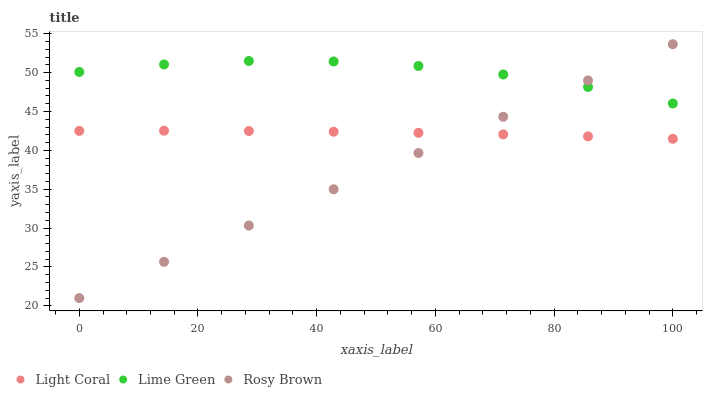Does Rosy Brown have the minimum area under the curve?
Answer yes or no. Yes. Does Lime Green have the maximum area under the curve?
Answer yes or no. Yes. Does Lime Green have the minimum area under the curve?
Answer yes or no. No. Does Rosy Brown have the maximum area under the curve?
Answer yes or no. No. Is Rosy Brown the smoothest?
Answer yes or no. Yes. Is Lime Green the roughest?
Answer yes or no. Yes. Is Lime Green the smoothest?
Answer yes or no. No. Is Rosy Brown the roughest?
Answer yes or no. No. Does Rosy Brown have the lowest value?
Answer yes or no. Yes. Does Lime Green have the lowest value?
Answer yes or no. No. Does Rosy Brown have the highest value?
Answer yes or no. Yes. Does Lime Green have the highest value?
Answer yes or no. No. Is Light Coral less than Lime Green?
Answer yes or no. Yes. Is Lime Green greater than Light Coral?
Answer yes or no. Yes. Does Lime Green intersect Rosy Brown?
Answer yes or no. Yes. Is Lime Green less than Rosy Brown?
Answer yes or no. No. Is Lime Green greater than Rosy Brown?
Answer yes or no. No. Does Light Coral intersect Lime Green?
Answer yes or no. No. 